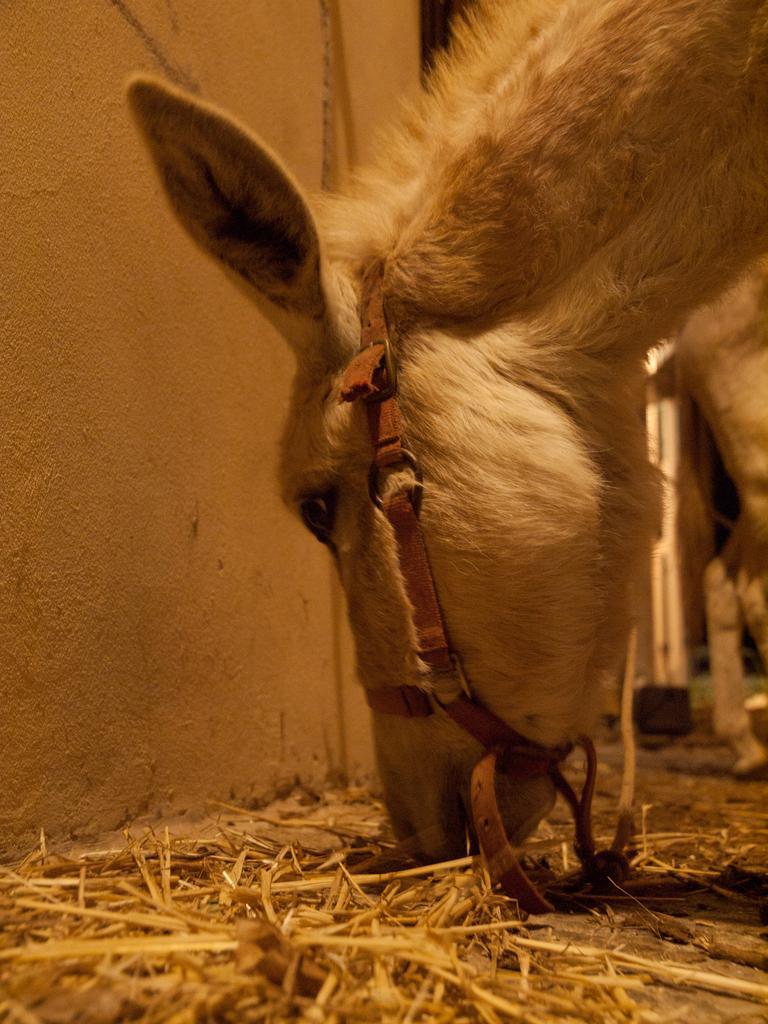Can you describe this image briefly? In this image there is a horse eating grass, at the bottom there is grass and in the background there is wall and some objects. 